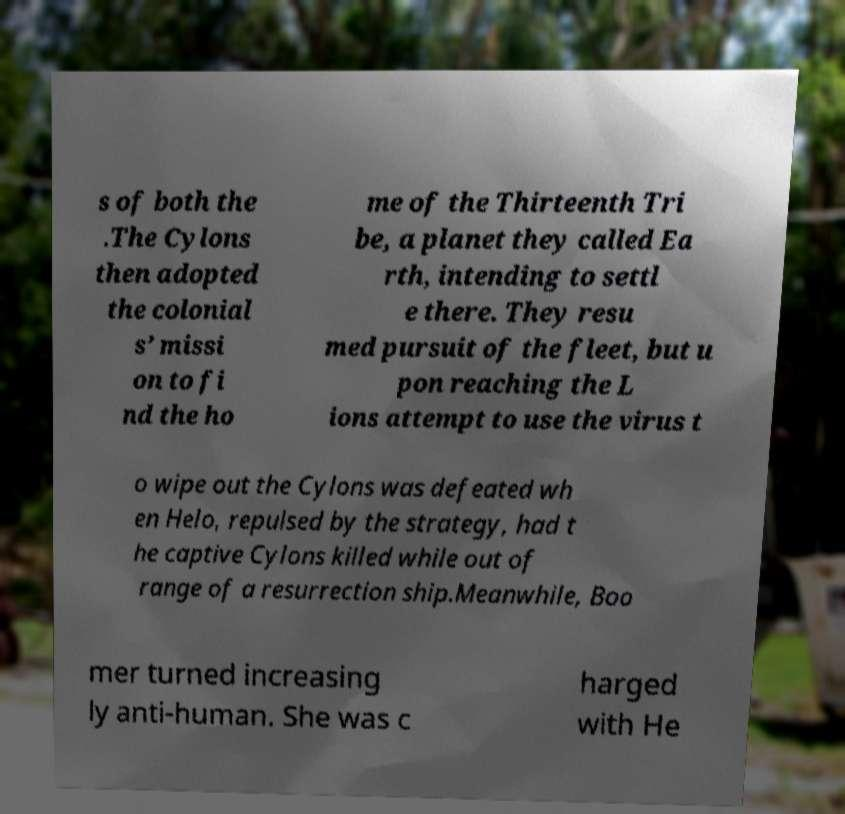Can you read and provide the text displayed in the image?This photo seems to have some interesting text. Can you extract and type it out for me? s of both the .The Cylons then adopted the colonial s’ missi on to fi nd the ho me of the Thirteenth Tri be, a planet they called Ea rth, intending to settl e there. They resu med pursuit of the fleet, but u pon reaching the L ions attempt to use the virus t o wipe out the Cylons was defeated wh en Helo, repulsed by the strategy, had t he captive Cylons killed while out of range of a resurrection ship.Meanwhile, Boo mer turned increasing ly anti-human. She was c harged with He 